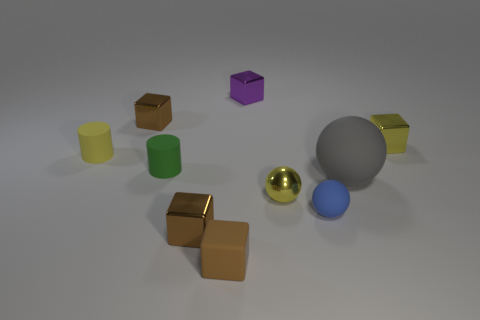How many brown blocks must be subtracted to get 1 brown blocks? 2 Subtract all tiny spheres. How many spheres are left? 1 Subtract all green cylinders. How many cylinders are left? 1 Subtract all balls. How many objects are left? 7 Add 8 blue rubber objects. How many blue rubber objects are left? 9 Add 2 yellow cylinders. How many yellow cylinders exist? 3 Subtract 0 green cubes. How many objects are left? 10 Subtract 2 cylinders. How many cylinders are left? 0 Subtract all green blocks. Subtract all gray cylinders. How many blocks are left? 5 Subtract all purple balls. How many green cubes are left? 0 